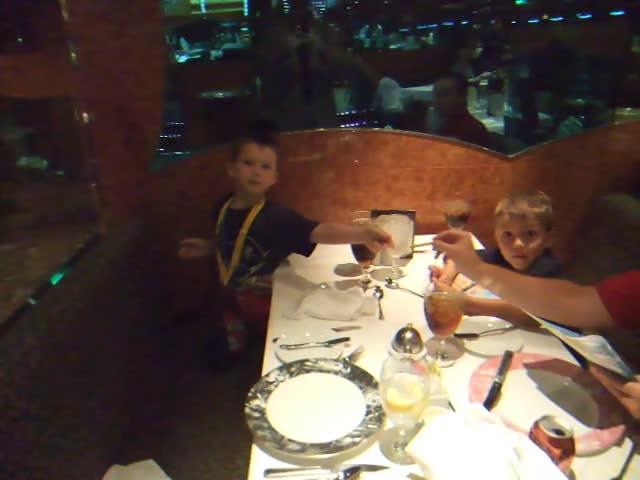What color is the lanyard string worn around the little boy's neck? Please explain your reasoning. yellow. The color is yellow. 